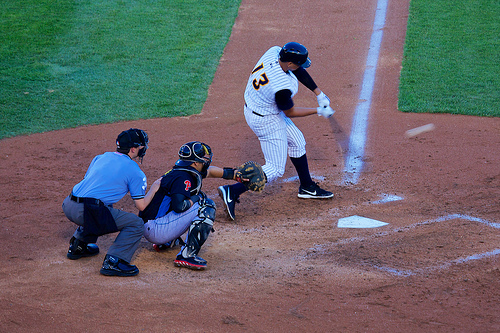Who is wearing the pants? The player, equipped for the game, wears the standard white baseball pants. 